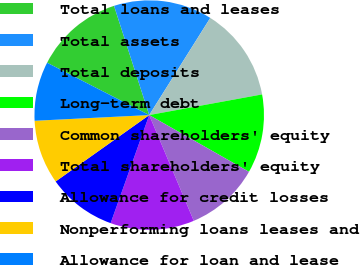<chart> <loc_0><loc_0><loc_500><loc_500><pie_chart><fcel>Total loans and leases<fcel>Total assets<fcel>Total deposits<fcel>Long-term debt<fcel>Common shareholders' equity<fcel>Total shareholders' equity<fcel>Allowance for credit losses<fcel>Nonperforming loans leases and<fcel>Allowance for loan and lease<nl><fcel>12.5%<fcel>13.89%<fcel>13.19%<fcel>11.11%<fcel>10.42%<fcel>11.81%<fcel>9.72%<fcel>9.03%<fcel>8.33%<nl></chart> 